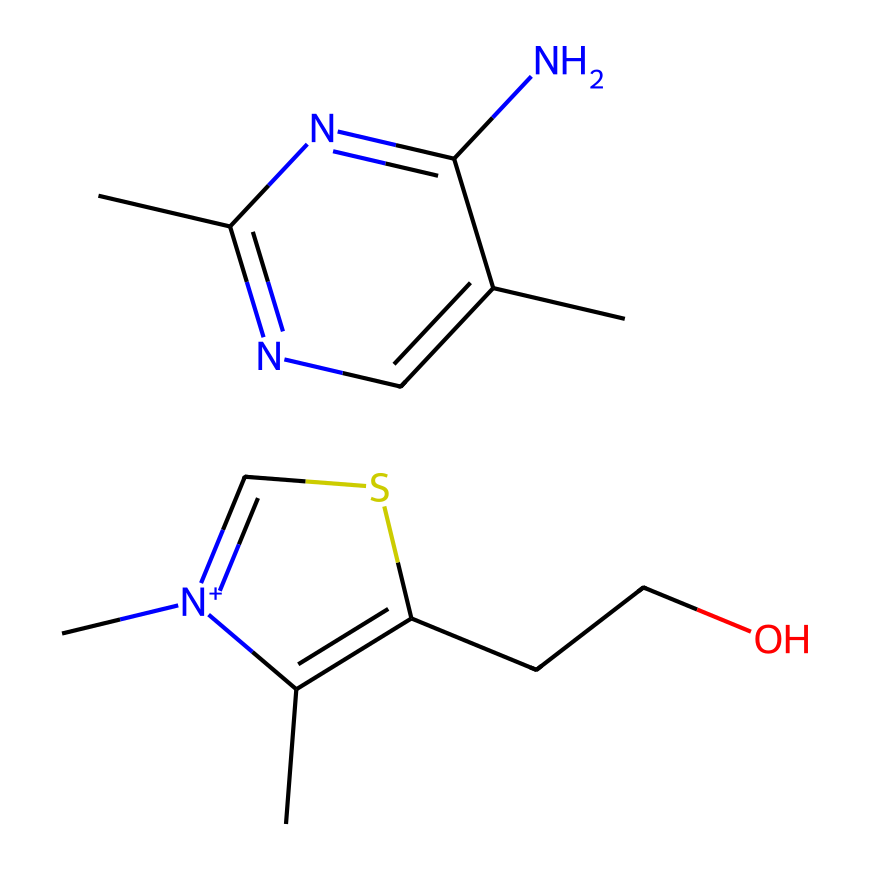What is the molecular formula of thiamine? By analyzing the SMILES representation, each atom type can be counted. Carbon (C) atoms total 11, nitrogen (N) atoms total 3, oxygen (O) atoms total 1, and sulfur (S) atoms total 1. Combining these gives the molecular formula C11H15N3OS.
Answer: C11H15N3OS How many nitrogen atoms are present in this compound? The SMILES shows multiple nitrogen components: specifically looking at "N" in the structure there are three occurrences, indicating there are three nitrogen atoms.
Answer: 3 What hybridization do the nitrogen atoms in thiamine predominantly exhibit? In the structure of thiamine, the nitrogen atoms are typically involved in aromatic systems or bonds with adjacent carbon; hence, they generally exhibit sp2 hybridization.
Answer: sp2 Which atom is responsible for the organosulfur classification of this compound? The SMILES contains the element sulfur (S). Organosulfur compounds are characterized by the inclusion of sulfur in their structure, making it the key atom for classification.
Answer: sulfur What is the primary role of thiamine in Yorkshire's traditional ales? Thiamine acts as a coenzyme in carbohydrate metabolism, contributing to the brewing process by facilitating the conversion of sugars during fermentation, which is essential in ale production.
Answer: coenzyme Which part of the molecule indicates the presence of a heterocyclic structure? The ring structure containing nitrogen and carbon atoms in the compound represents a heterocyclic component, specifically the cyclic arrangement of atoms.
Answer: heterocyclic structure What is the significance of the sulfonium ion in thiamine's structure? The sulfonium ion contributes to the overall functionality of thiamine as a coenzyme and aids in its biological activity, particularly in enzymatic reactions related to metabolism.
Answer: biological activity 